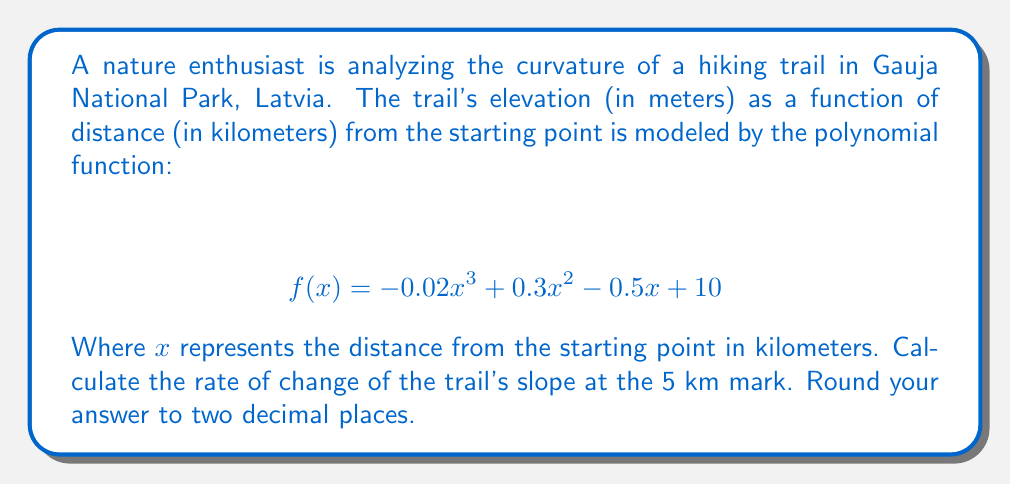What is the answer to this math problem? To find the rate of change of the trail's slope at the 5 km mark, we need to follow these steps:

1) The slope of the trail is given by the first derivative of the function:
   $$ f'(x) = -0.06x^2 + 0.6x - 0.5 $$

2) The rate of change of the slope is given by the second derivative:
   $$ f''(x) = -0.12x + 0.6 $$

3) We need to evaluate $f''(x)$ at $x = 5$:
   $$ f''(5) = -0.12(5) + 0.6 $$
   $$ f''(5) = -0.6 + 0.6 $$
   $$ f''(5) = 0 $$

4) Therefore, the rate of change of the slope at the 5 km mark is 0 m/km².

This result indicates that at the 5 km mark, the trail's curvature is at an inflection point, transitioning from concave up to concave down (or vice versa).
Answer: 0 m/km² 